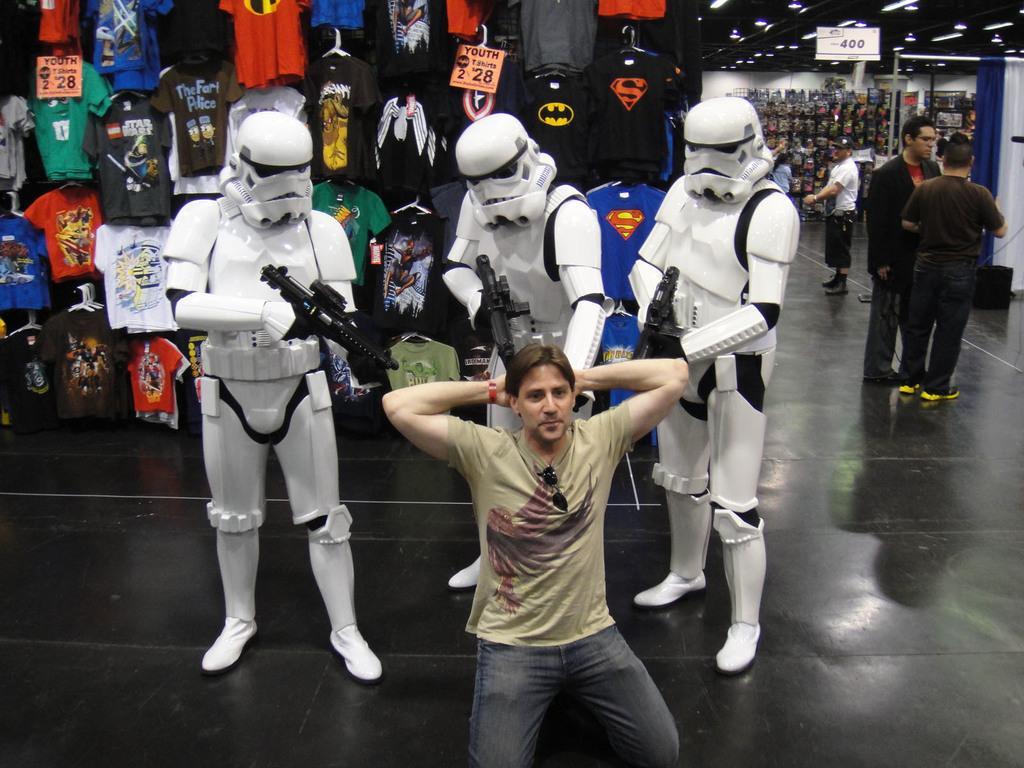How would you summarize this image in a sentence or two? In this picture there are three persons who are wearing white armor and holding a gun. In front of them there is a man who is in squat position and he is wearing goggles, t-shirt, watch and jeans. On the right there are two persons who are standing near to the pipe. On the left I can see many t-shirts which are placed on the hangers. In the back I can see other clothes which are placed in the wooden racks. In the top right corner I can see the price tag and tube lights. 